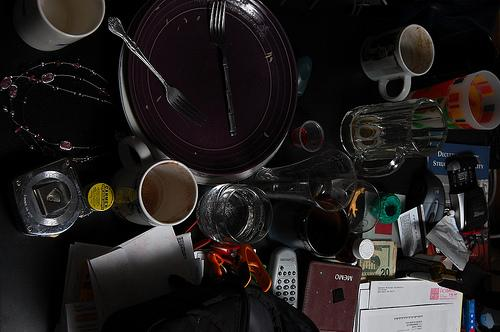Select the task where the goal is to find the object mentioned in a text, within an image. Referential expression grounding task In a visual entailment task, evaluate the truthfulness of this statement: "The table in the image is clean and has no items on it." The statement is false because the table is filled with dishes, utensils, and other items, making it cluttered and dirty. If you are taking part in a multi-choice VQA task, name one possible question about the image that needs answering. Carmex lip balm to heal dry lips. Which task involves answering questions based on the information provided in the image? Multi-choice VQA task Comment on the overall state and content of the table in a visual entailment task. The table is cluttered and filled with various items, including dirty dishes, utensils, cups, a necklace, remote controls, and money. Describe what you might be advertising if you were to use this image in a product advertisement task. I would be advertising a home cleaning or dishwashing product, emphasizing its effectiveness on dirty dishes, utensils, and table clutter. What is the main focus of the visual entailment task in the context of an image? Determining if a given textual description logically follows or contradicts the content of the image. 